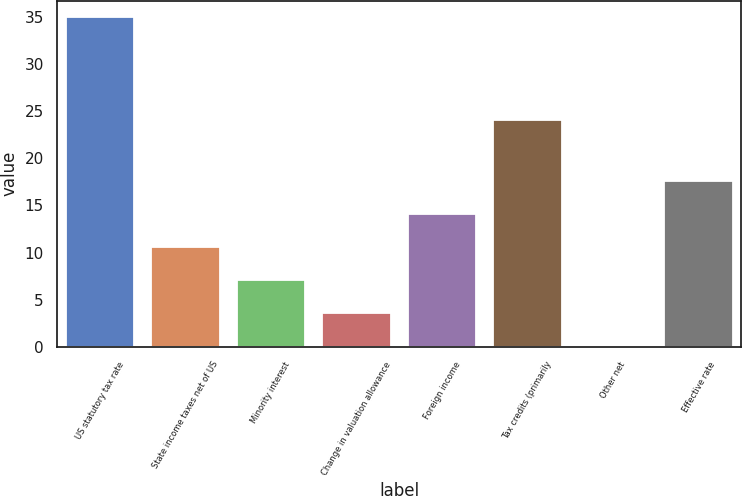<chart> <loc_0><loc_0><loc_500><loc_500><bar_chart><fcel>US statutory tax rate<fcel>State income taxes net of US<fcel>Minority interest<fcel>Change in valuation allowance<fcel>Foreign income<fcel>Tax credits (primarily<fcel>Other net<fcel>Effective rate<nl><fcel>35<fcel>10.57<fcel>7.08<fcel>3.59<fcel>14.06<fcel>24.1<fcel>0.1<fcel>17.55<nl></chart> 